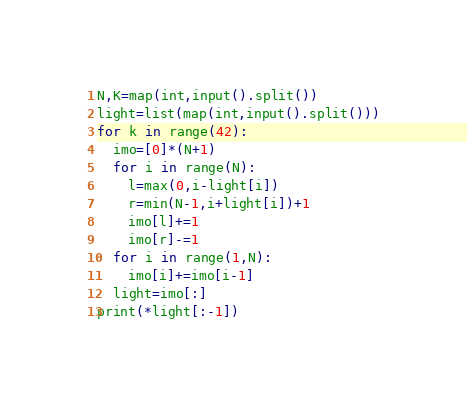Convert code to text. <code><loc_0><loc_0><loc_500><loc_500><_Python_>N,K=map(int,input().split())
light=list(map(int,input().split()))
for k in range(42):
  imo=[0]*(N+1)
  for i in range(N):
    l=max(0,i-light[i])
    r=min(N-1,i+light[i])+1
    imo[l]+=1
    imo[r]-=1
  for i in range(1,N):
    imo[i]+=imo[i-1]
  light=imo[:]
print(*light[:-1])</code> 